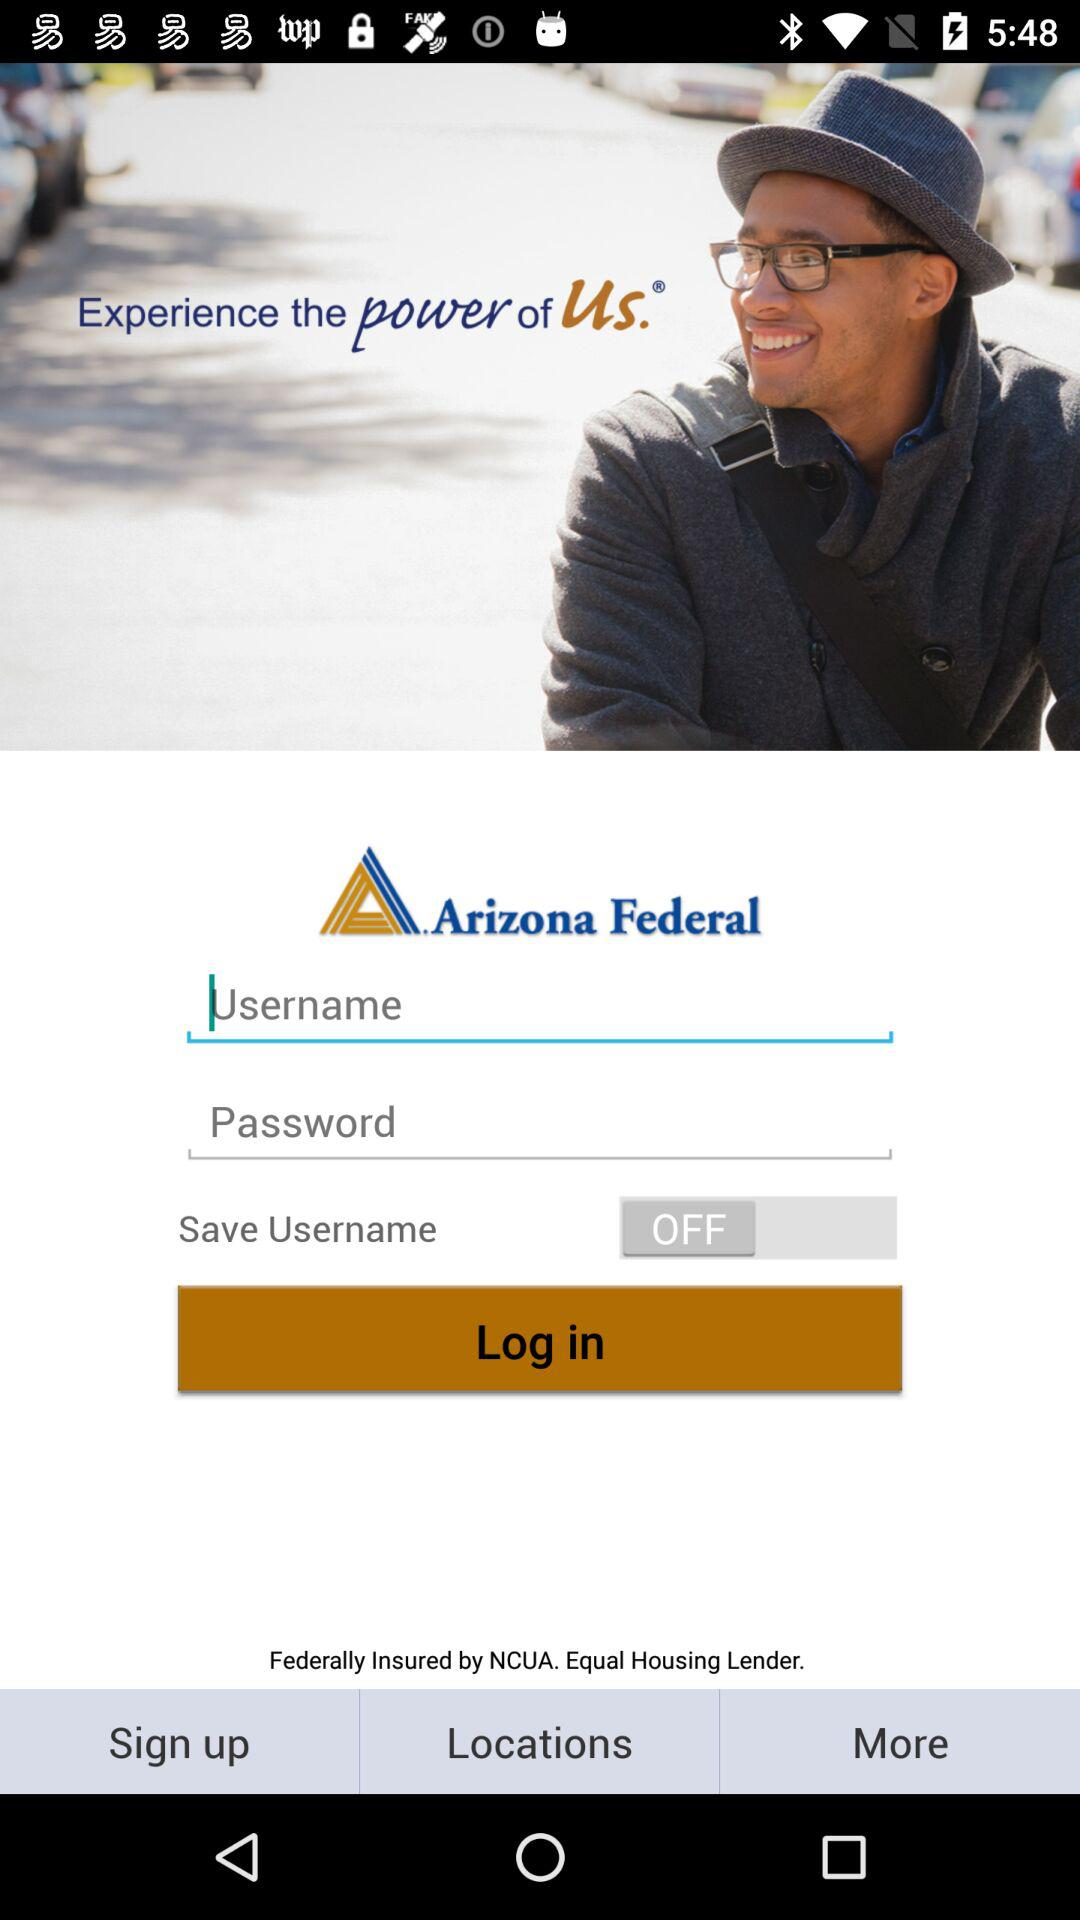How many fields are there to fill out?
Answer the question using a single word or phrase. 2 